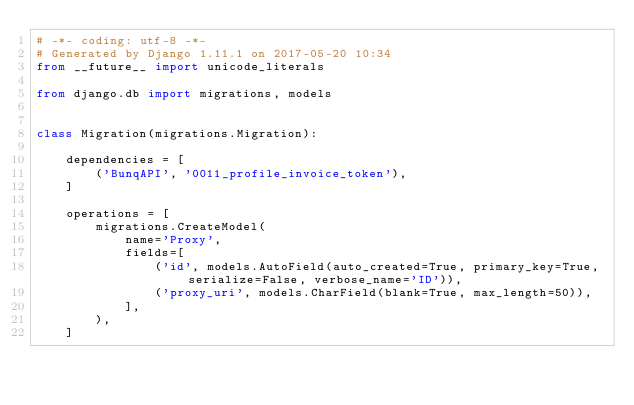Convert code to text. <code><loc_0><loc_0><loc_500><loc_500><_Python_># -*- coding: utf-8 -*-
# Generated by Django 1.11.1 on 2017-05-20 10:34
from __future__ import unicode_literals

from django.db import migrations, models


class Migration(migrations.Migration):

    dependencies = [
        ('BunqAPI', '0011_profile_invoice_token'),
    ]

    operations = [
        migrations.CreateModel(
            name='Proxy',
            fields=[
                ('id', models.AutoField(auto_created=True, primary_key=True, serialize=False, verbose_name='ID')),
                ('proxy_uri', models.CharField(blank=True, max_length=50)),
            ],
        ),
    ]
</code> 